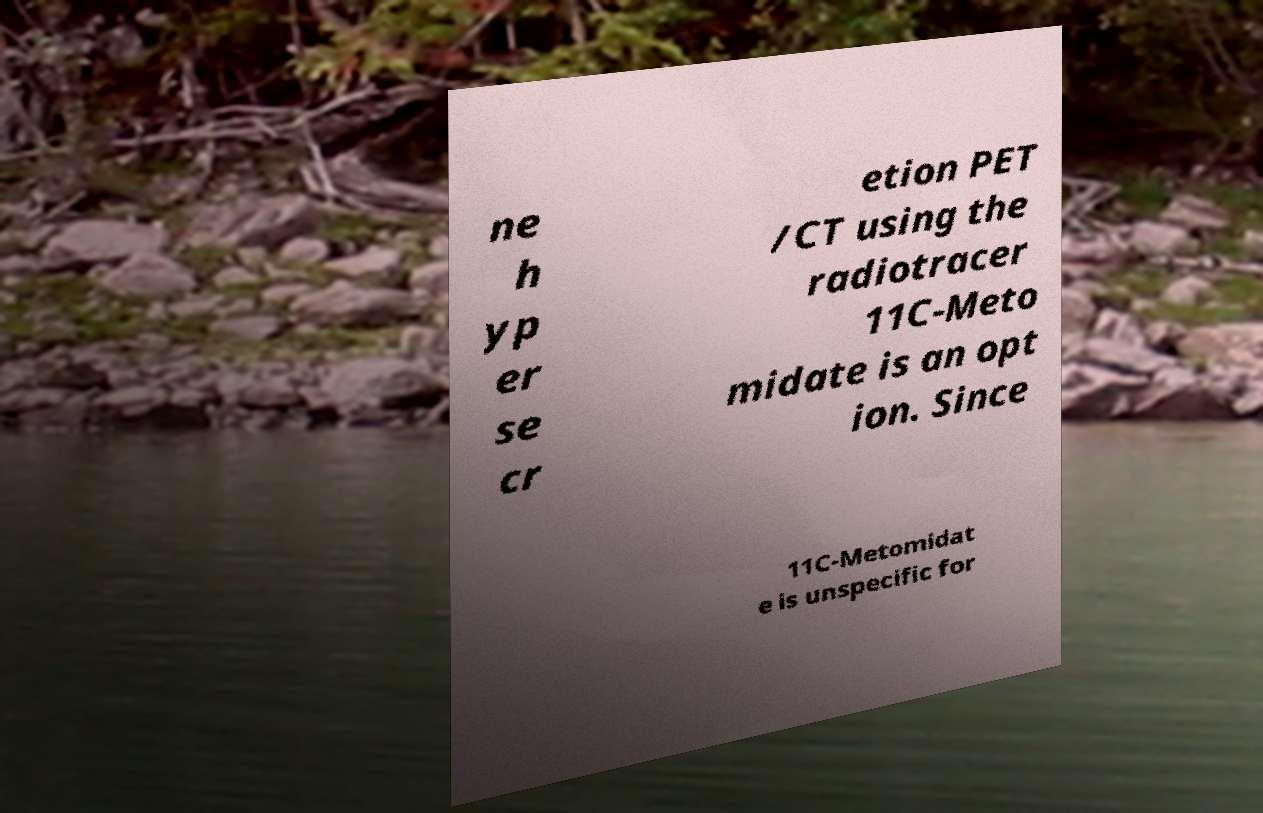Can you accurately transcribe the text from the provided image for me? ne h yp er se cr etion PET /CT using the radiotracer 11C-Meto midate is an opt ion. Since 11C-Metomidat e is unspecific for 